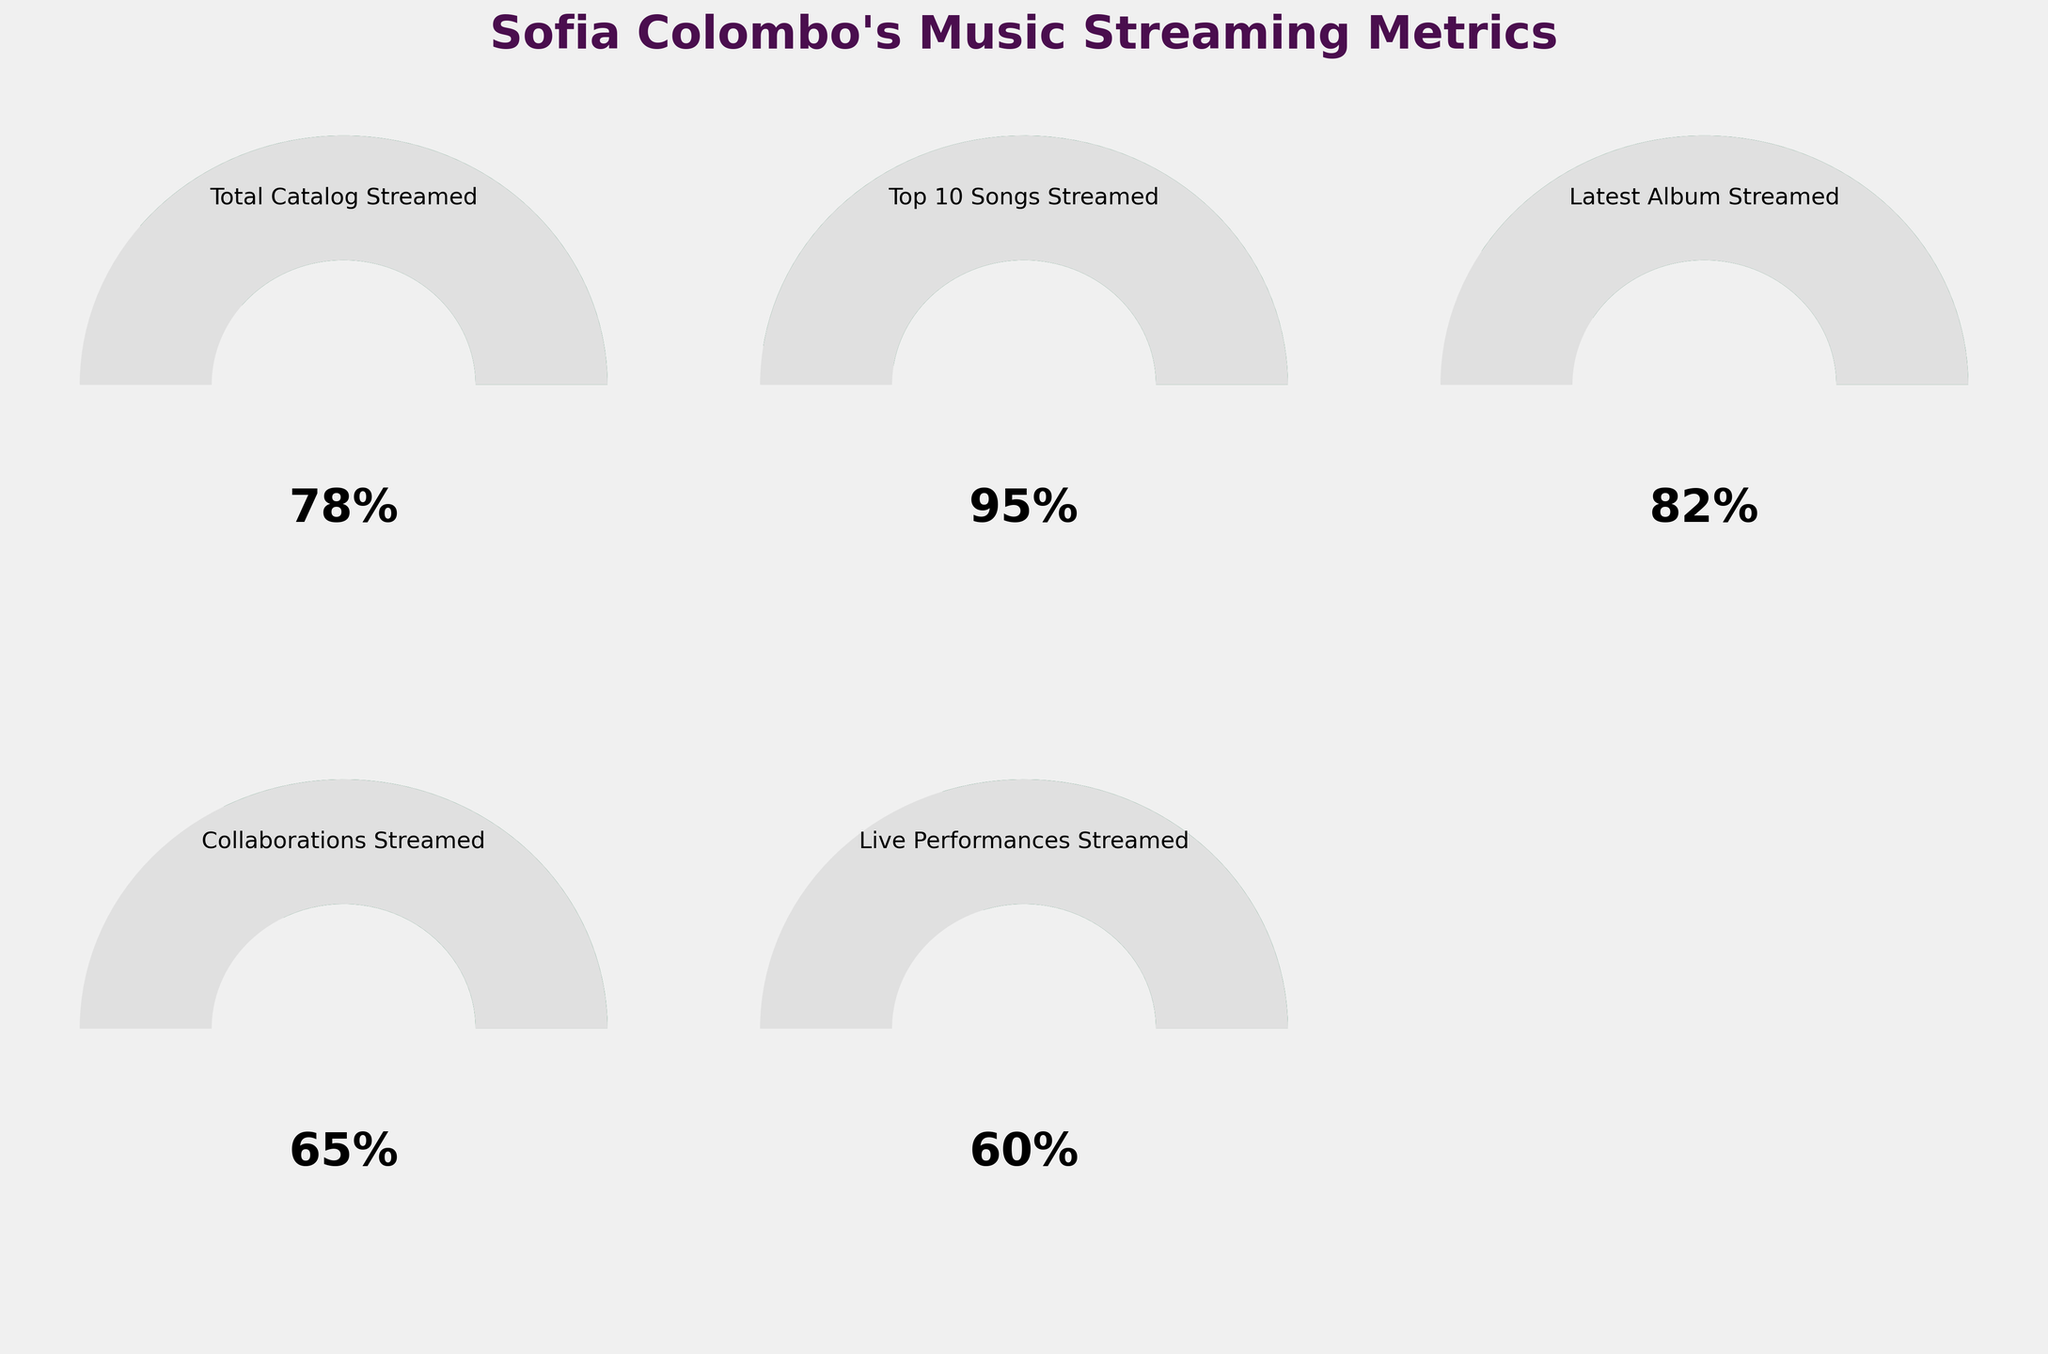What's the percentage of Sofia Colombo's total catalog streamed last month? The gauge chart representing "Total Catalog Streamed" shows a needle pointing to 78%, indicating that 78% of her total catalog was streamed last month.
Answer: 78% What is the difference in streaming percentage between Sofia Colombo's top 10 songs and her collaborations? Sofia Colombo's top 10 songs have a streaming percentage of 95%, while her collaborations have a percentage of 65%. The difference is 95% - 65% = 30%.
Answer: 30% Which category has the highest streaming percentage? Comparing all the gauges, "Top 10 Songs Streamed" has the highest percentage at 95%.
Answer: Top 10 Songs Streamed What is the average streaming percentage of Sofia Colombo's latest album and live performances? The latest album has a streaming percentage of 82%, and live performances have 60%. The average is calculated as (82% + 60%) / 2 = 142% / 2 = 71%.
Answer: 71% Among the listed categories, which has the lowest streaming percentage? Comparing the streaming percentages of all categories, "Live Performances Streamed" has the lowest percentage at 60%.
Answer: Live Performances Streamed How much more popular were the latest album streams compared to the live performances? The latest album's streaming percentage is 82%, while live performances are at 60%. The difference is 82% - 60% = 22%.
Answer: 22% Is the percentage of live performances streamed higher or lower than the collaborations streamed? The live performances have a streaming percentage of 60%, while collaborations are at 65%. Therefore, live performances are lower than collaborations.
Answer: Lower What is the combined streaming percentage of the top 10 songs and the latest album? The top 10 songs have a streaming percentage of 95%, and the latest album is at 82%. The combined percentage is 95% + 82% = 177%.
Answer: 177% What is the gauge color for the live performances streamed metric on the plot? The gauge for "Live Performances Streamed" is predominantly red-orange, indicating streaming within the 60% range.
Answer: Red-Orange 